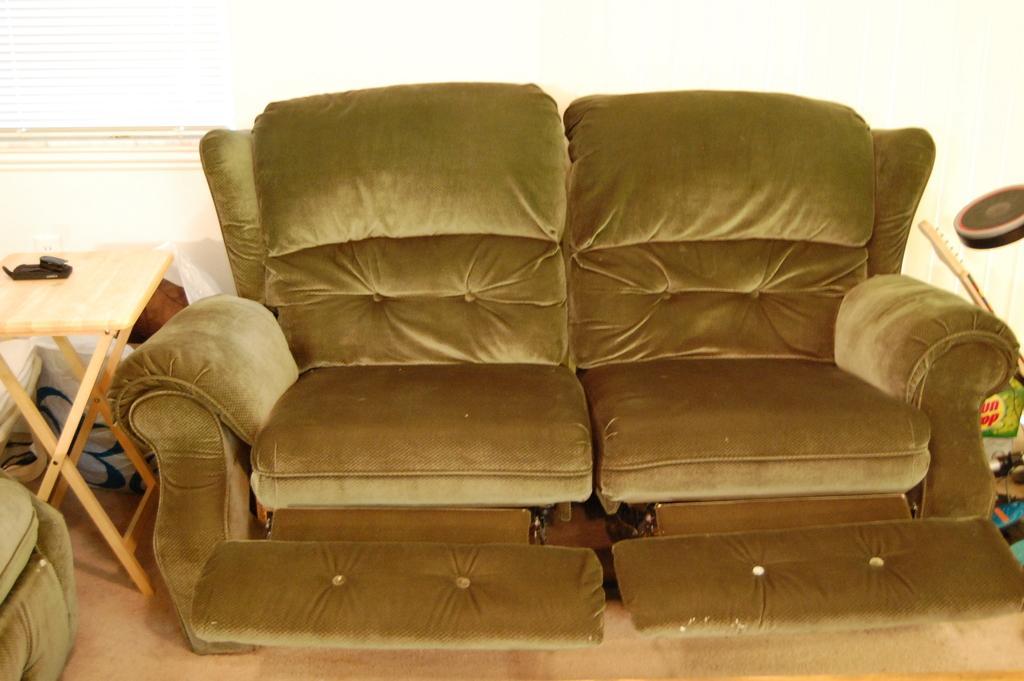In one or two sentences, can you explain what this image depicts? In the image there is a recliner sofa and beside it there is a table. 